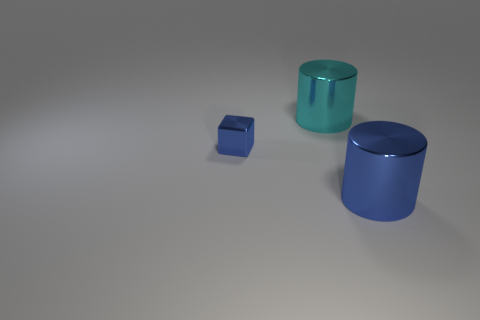Add 3 metal cubes. How many objects exist? 6 Subtract all blue cylinders. How many cylinders are left? 1 Subtract all cylinders. How many objects are left? 1 Subtract all cyan cylinders. Subtract all gray balls. How many cylinders are left? 1 Subtract all yellow blocks. How many cyan cylinders are left? 1 Subtract all small purple cylinders. Subtract all big things. How many objects are left? 1 Add 1 big blue objects. How many big blue objects are left? 2 Add 2 cyan things. How many cyan things exist? 3 Subtract 1 cyan cylinders. How many objects are left? 2 